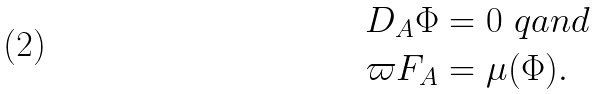<formula> <loc_0><loc_0><loc_500><loc_500>\sl D _ { A } \Phi & = 0 \ q a n d \\ \varpi F _ { A } & = \mu ( \Phi ) .</formula> 